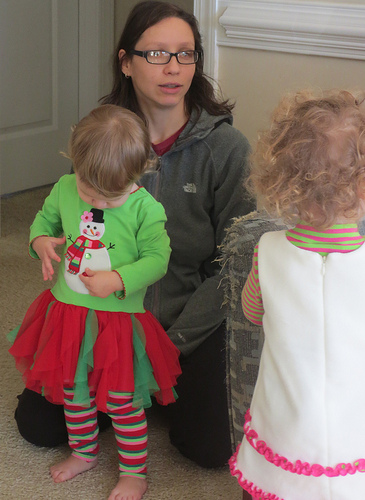<image>
Is the mom behind the baby? Yes. From this viewpoint, the mom is positioned behind the baby, with the baby partially or fully occluding the mom. Where is the snowman in relation to the glasses? Is it next to the glasses? No. The snowman is not positioned next to the glasses. They are located in different areas of the scene. 